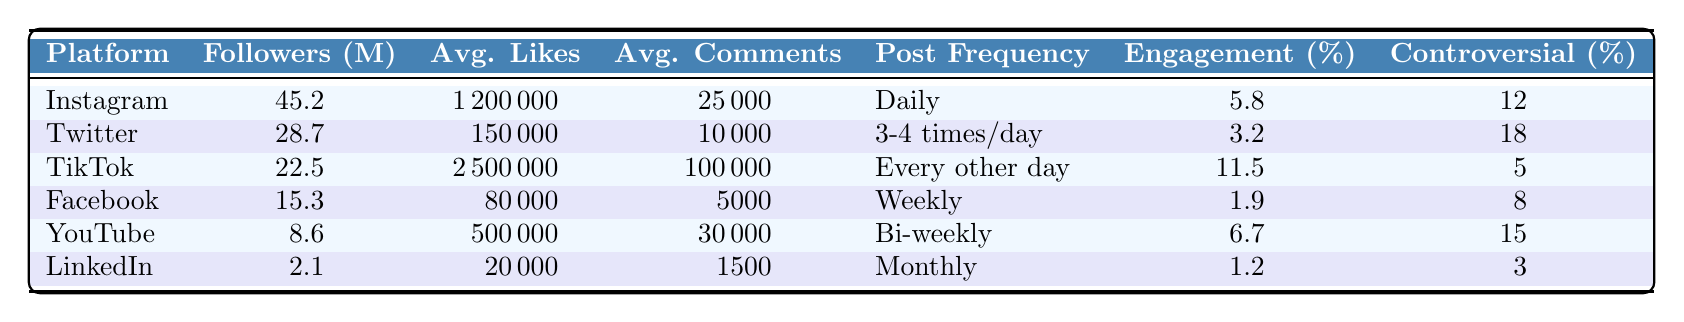What platform has the highest number of followers? By looking at the "Followers (millions)" column, Instagram has 45.2 million followers, which is the highest among all platforms listed.
Answer: Instagram What is the average engagement rate for TikTok? The "Engagement Rate (%)" column shows that TikTok has an engagement rate of 11.5%.
Answer: 11.5% How often does the actor post on Facebook? The "Post Frequency" column indicates that the actor posts on Facebook weekly.
Answer: Weekly Which platform has the lowest average likes per post? The "Avg. Likes per Post" column shows LinkedIn has the lowest average likes with 20,000 likes per post.
Answer: LinkedIn What is the average number of comments per post across all platforms? Adding the average comments: 25,000 + 10,000 + 100,000 + 5,000 + 30,000 + 1,500 = 171,500. There are 6 platforms, so the average is 171,500 / 6 = 28,583.33 (approximately).
Answer: 28,583.33 Is the engagement rate on Twitter higher than on YouTube? Twitter has an engagement rate of 3.2%, while YouTube has 6.7%. Comparing these values, YouTube has a higher engagement rate than Twitter.
Answer: No Which platform has the least controversial posts percentage? Looking at the "Controversial Posts (%)" column, LinkedIn has the lowest percentage with 3%.
Answer: LinkedIn Calculate the total number of followers across all platforms. Adding the followers: 45.2 + 28.7 + 22.5 + 15.3 + 8.6 + 2.1 = 122.4 million.
Answer: 122.4 million How many platforms have an engagement rate above 5%? The platforms with engagement rates above 5% are Instagram (5.8%), TikTok (11.5%), and YouTube (6.7%). That makes 3 platforms.
Answer: 3 platforms On which platform do posts receive the most average comments? The "Avg. Comments per Post" column shows that TikTok has the highest average comments at 100,000 per post.
Answer: TikTok 